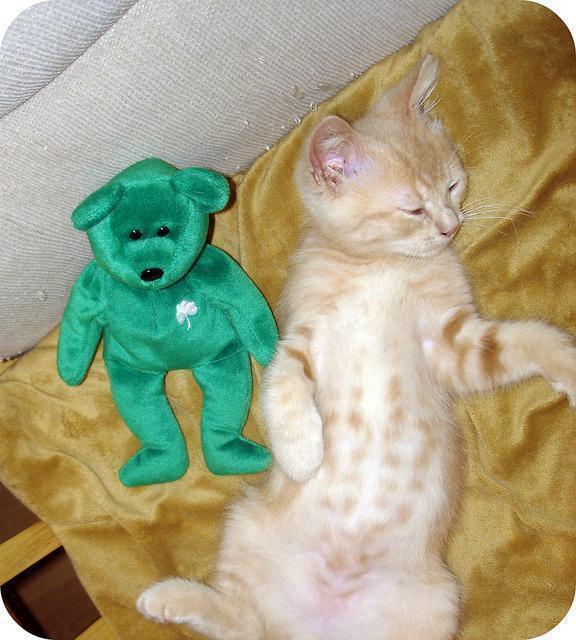What is the logo on the bear?
Select the accurate response from the four choices given to answer the question.
Options: Maple, cotton, ball, shamrock. Shamrock. 